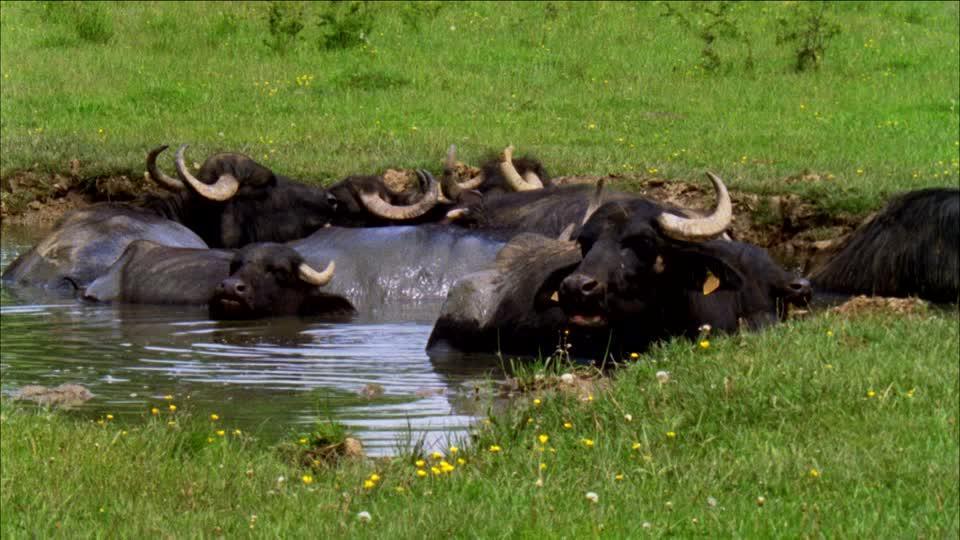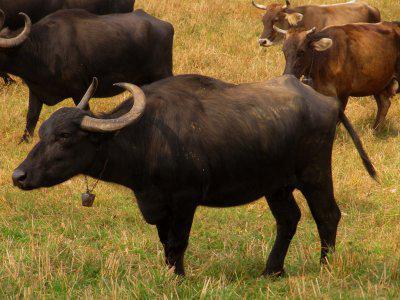The first image is the image on the left, the second image is the image on the right. For the images shown, is this caption "In at least one image, water buffalo are walking rightward down a street lined with buildings." true? Answer yes or no. No. The first image is the image on the left, the second image is the image on the right. Analyze the images presented: Is the assertion "The right image contains at least one water buffalo walking through a town on a dirt road." valid? Answer yes or no. No. 